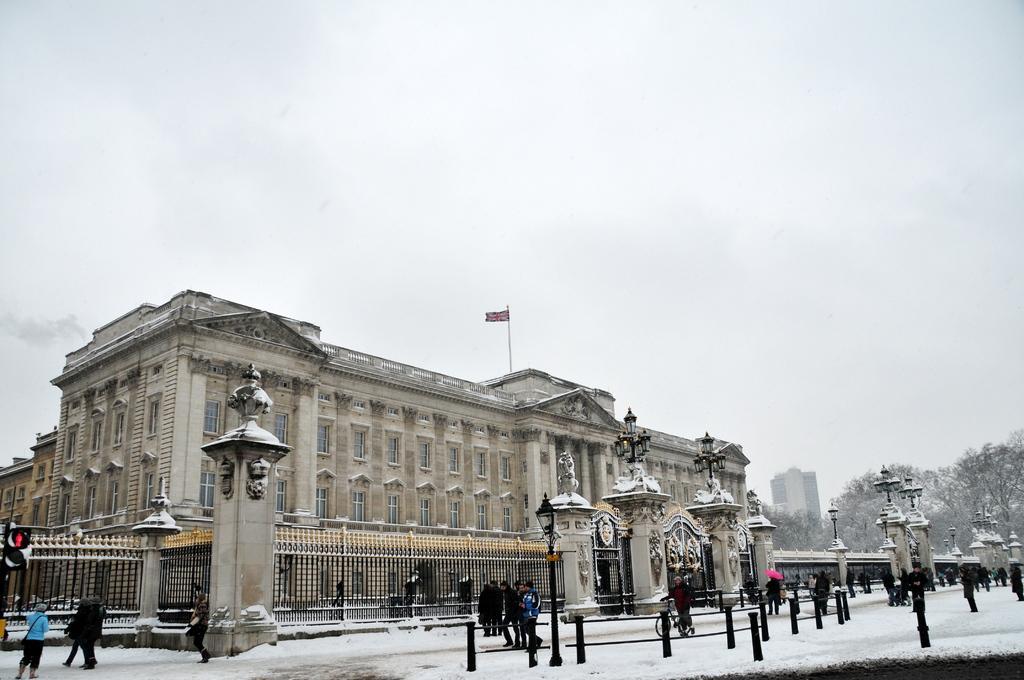Can you describe this image briefly? In this picture we can see people on the road, beside this road we can see buildings, trees and on one building we can see a flag, here we can see traffic signal, electric poles, bicycle, umbrella, metal poles and some objects and we can see sky in the background. 